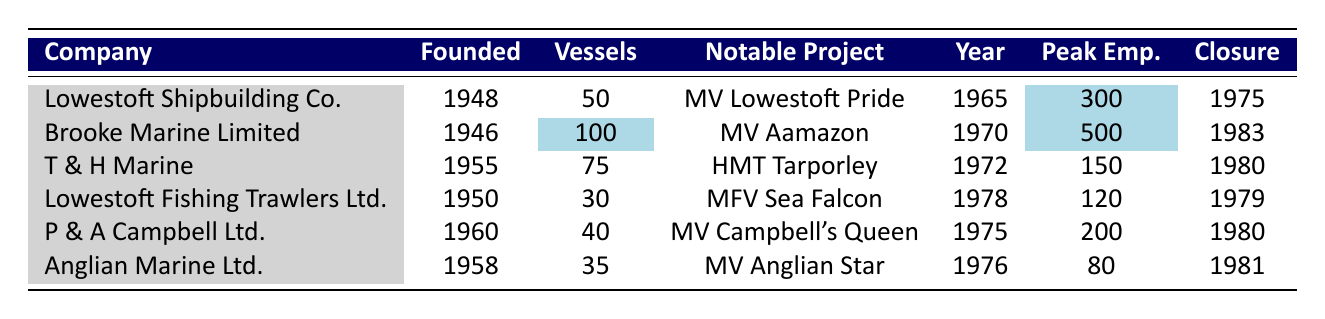What was the year of closure for Lowestoft Shipbuilding Company? Looking at the table, the "Lowestoft Shipbuilding Company" row shows that its closure year is listed as 1975.
Answer: 1975 Which company built the most vessels? By comparing the "Vessels" column, "Brooke Marine Limited" built the most with 100 significant vessels.
Answer: 100 Did T & H Marine have an employment peak of more than 150? Checking the peak employment numbers in the "Peak Emp." column, T & H Marine had a peak of 150, which is not more than 150.
Answer: No What is the total number of significant vessels built by all companies combined? The total can be calculated by adding the vessels built: 50 + 100 + 75 + 30 + 40 + 35 = 330.
Answer: 330 Which company had the highest peak employment, and what was that number? Reviewing the "Peak Emp." column, "Brooke Marine Limited" had the highest peak employment at 500.
Answer: Brooke Marine Limited; 500 Is it true that all companies listed had their peak employment before 1980? The closure years of each company indicate that Lowestoft Shipbuilding Company, T & H Marine, and P & A Campbell Ltd. all ceased operations in or before 1980, while Brooke Marine Limited closed in 1983. Therefore, not all had peak employment before 1980.
Answer: No What is the average peak employment among these shipbuilding companies? To calculate the average, add all peak employment values: 300 + 500 + 150 + 120 + 200 + 80 = 1350; then divide by the number of companies (6): 1350 / 6 = 225.
Answer: 225 Which notable project was completed by Lowestoft Fishing Trawlers Ltd.? The notable project for Lowestoft Fishing Trawlers Ltd. as listed in the table is "MFV Sea Falcon."
Answer: MFV Sea Falcon Which shipbuilding company was founded first and in what year? By examining the "Founded" column, "Brooke Marine Limited" was founded first in 1946.
Answer: Brooke Marine Limited; 1946 How many years did T & H Marine operate before closing? T & H Marine was founded in 1955 and closed in 1980. The number of operating years is 1980 - 1955 = 25 years.
Answer: 25 years 